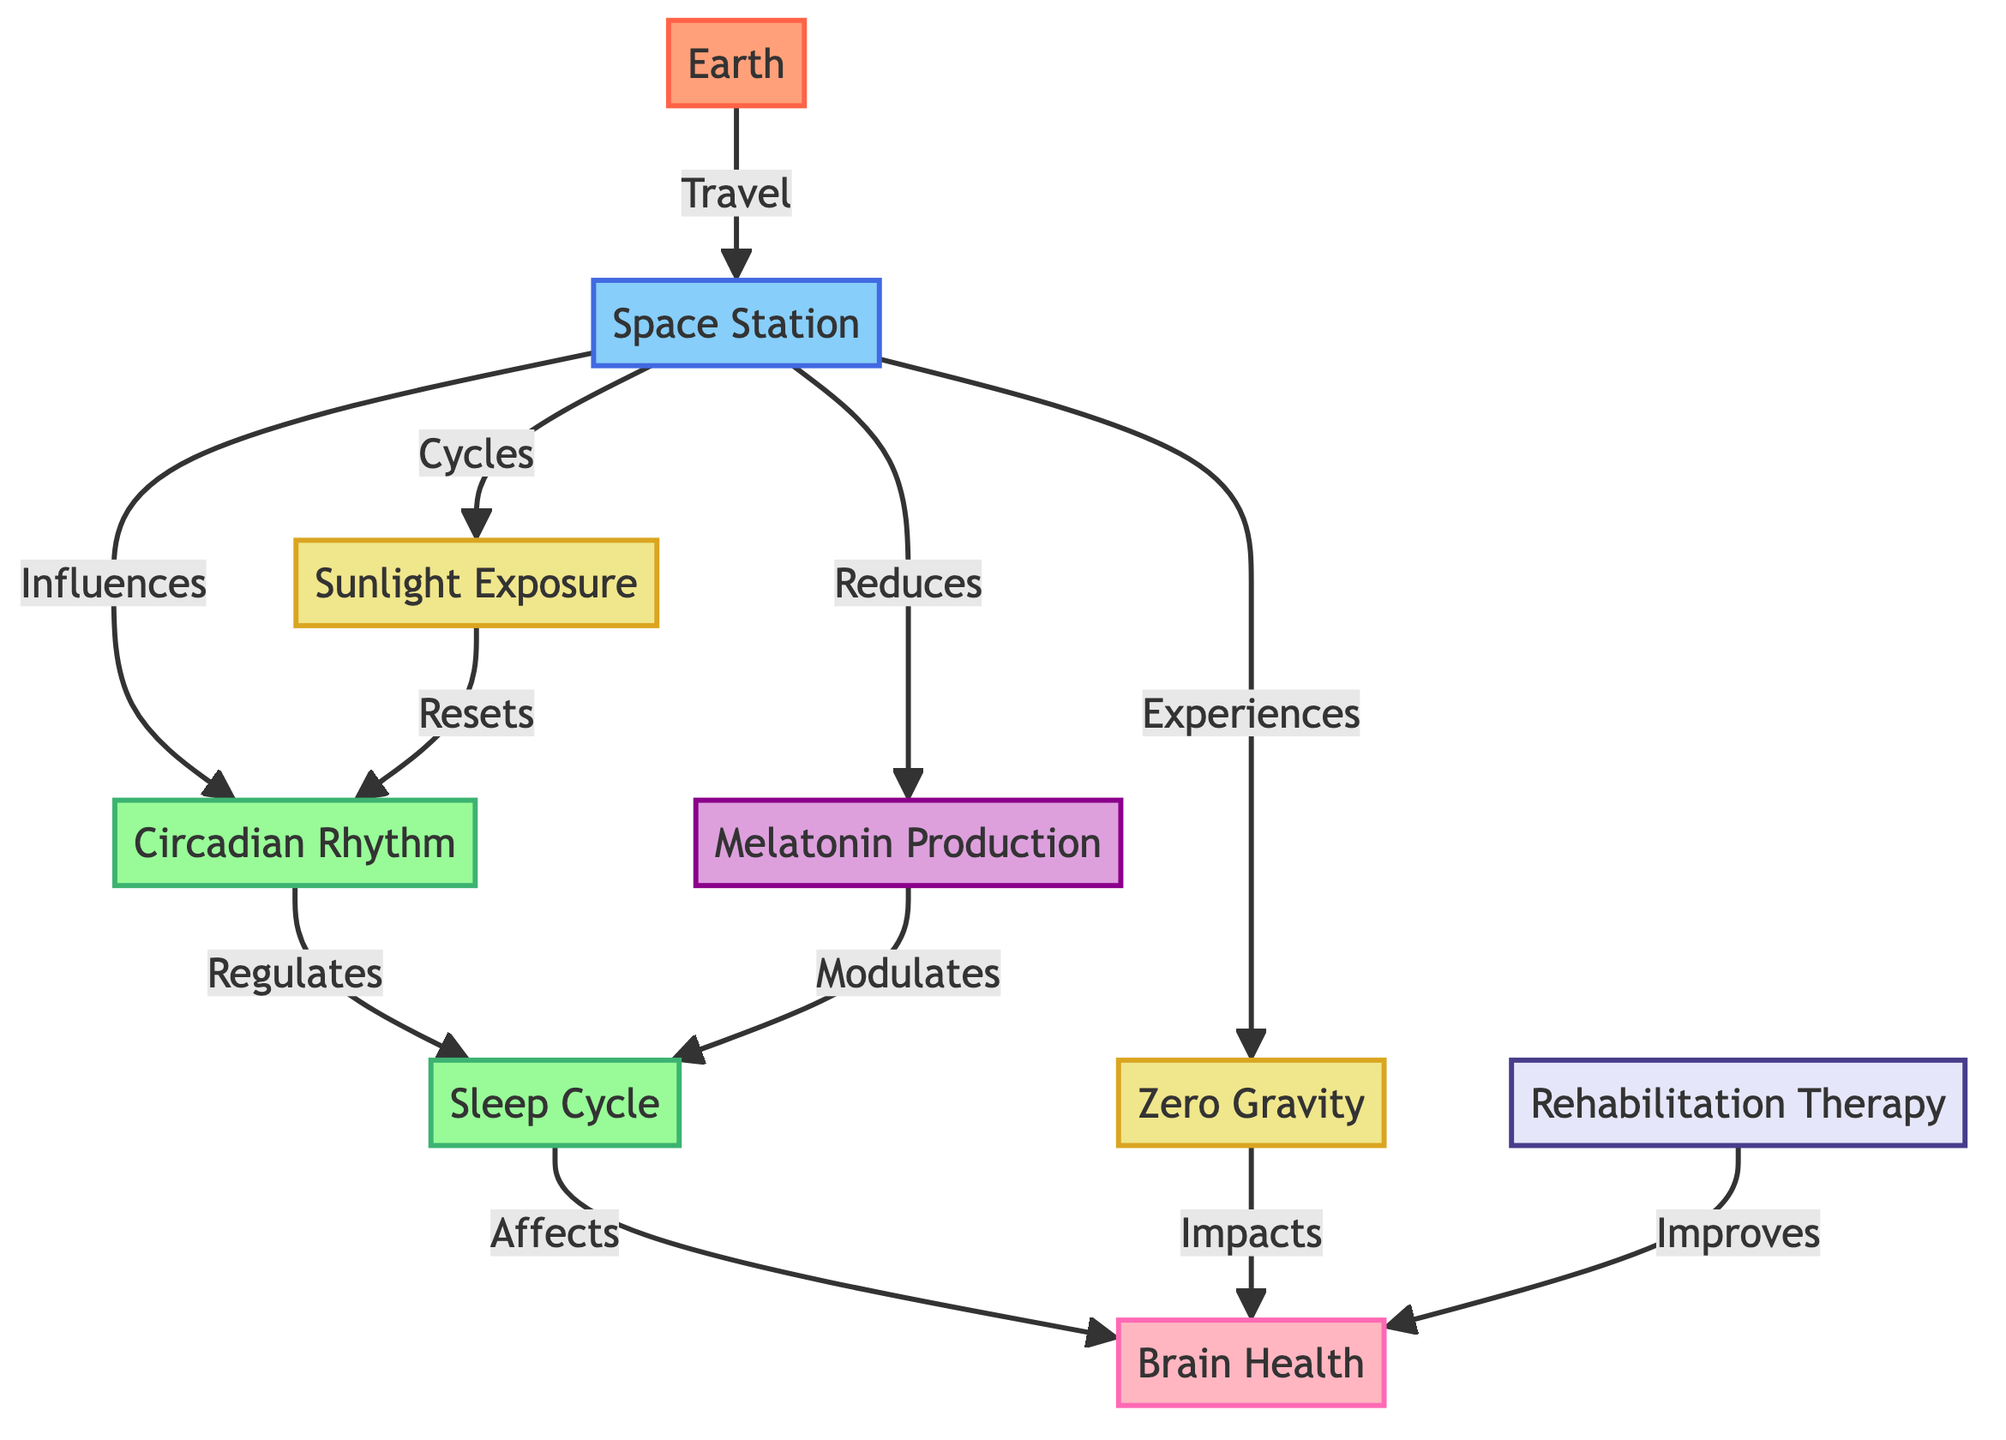What is the primary environment factor affecting brain health in space? The diagram shows that "zero gravity" is connected to "brain health," indicating that it is a primary environmental factor in this context.
Answer: zero gravity How many biological processes are linked to sleep cycle in the diagram? From the diagram, there are two biological processes connected to the "sleep cycle": "circadian rhythm" and "melatonin production."
Answer: 2 What does the space station influence? The diagram shows that the "space station" influences the "circadian rhythm," indicating a direct relationship.
Answer: circadian rhythm What therapy is indicated to improve brain health? The diagram lists "rehabilitation therapy" as a treatment that improves "brain health."
Answer: rehabilitation therapy How does sunlight exposure affect circadian rhythm? According to the diagram, "sunlight exposure" resets the "circadian rhythm," reflecting its role in regulating this biological process.
Answer: Resets How does melatonin production relate to sleep cycle? The diagram indicates that "melatonin production" modulates the "sleep cycle," showing a causal relationship between these two factors.
Answer: Modulates What is the effect of zero gravity on brain health? The diagram shows that "zero gravity" impacts "brain health," suggesting a detrimental or significant influence in space travel contexts.
Answer: Impacts How many nodes involve treatments in the diagram? There is one treatment node, which is "rehabilitation therapy," that is indicated in the diagram.
Answer: 1 What is the relationship between sleep cycle and brain health? The diagram connects "sleep cycle" to "brain health," implying that the former affects the latter.
Answer: Affects 